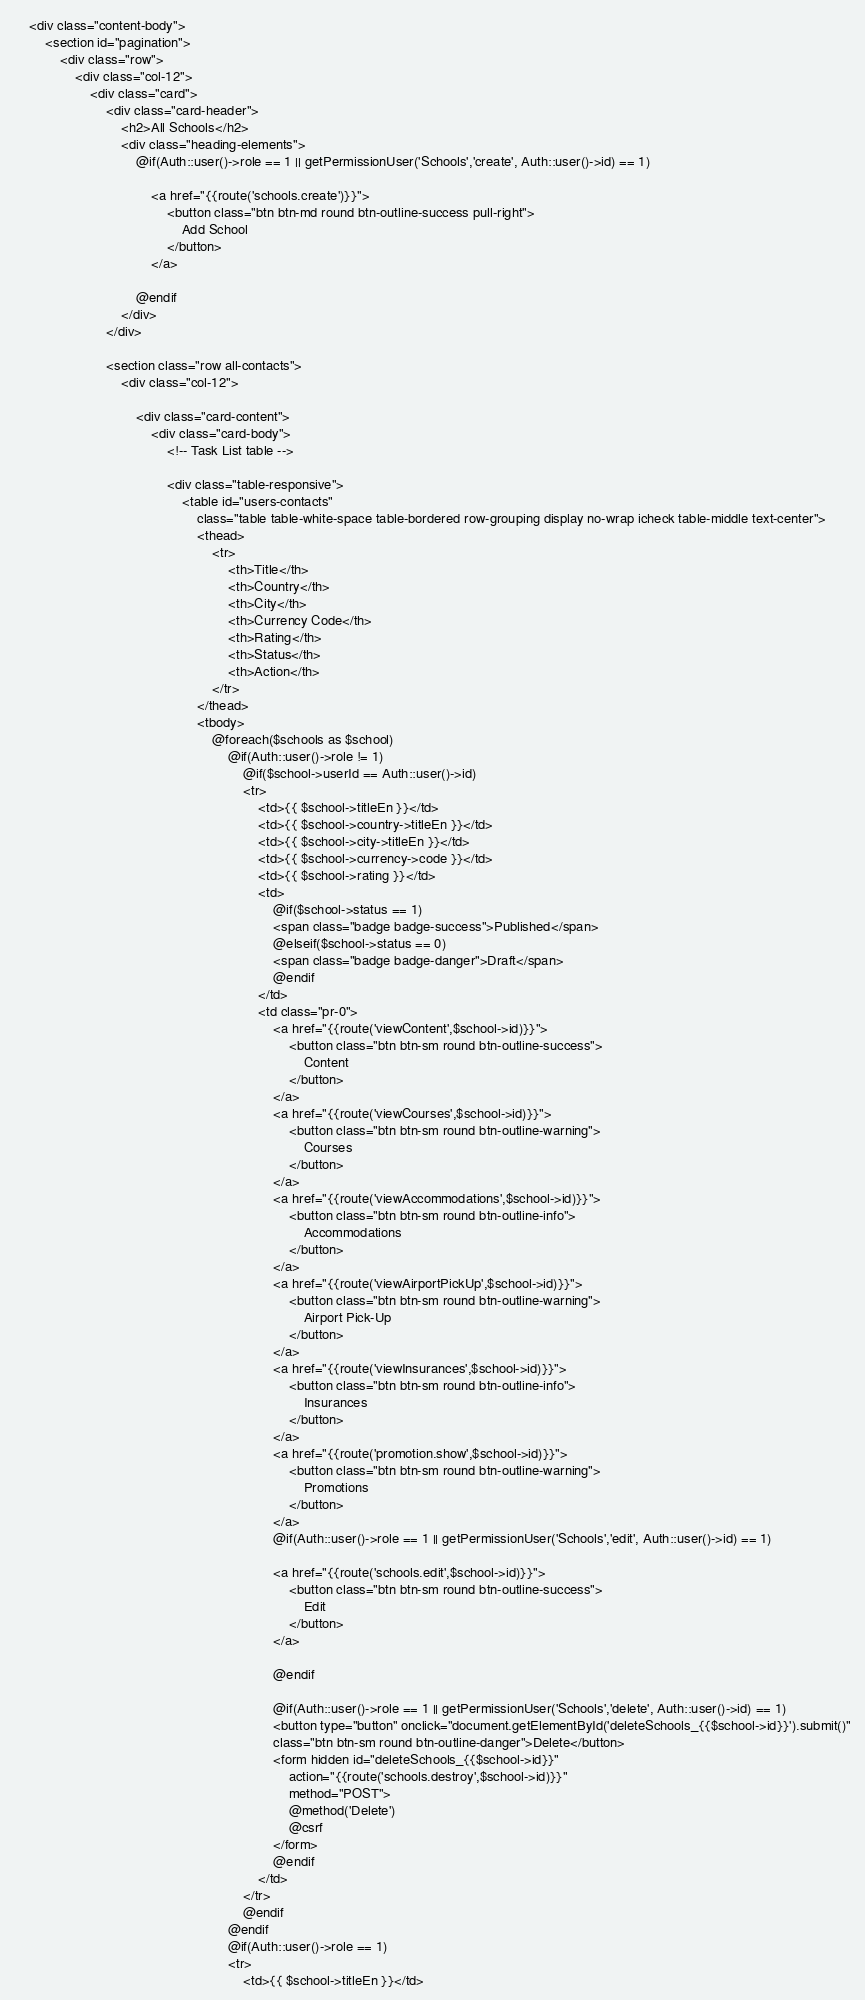<code> <loc_0><loc_0><loc_500><loc_500><_PHP_>    <div class="content-body">
        <section id="pagination">
            <div class="row">
                <div class="col-12">
                    <div class="card">
                        <div class="card-header">
                            <h2>All Schools</h2>
                            <div class="heading-elements">
                                @if(Auth::user()->role == 1 || getPermissionUser('Schools','create', Auth::user()->id) == 1)

                                    <a href="{{route('schools.create')}}">
                                        <button class="btn btn-md round btn-outline-success pull-right">
                                            Add School
                                        </button>
                                    </a>

                                @endif
                            </div>
                        </div>

                        <section class="row all-contacts">
                            <div class="col-12">

                                <div class="card-content">
                                    <div class="card-body">
                                        <!-- Task List table -->

                                        <div class="table-responsive">
                                            <table id="users-contacts"
                                                class="table table-white-space table-bordered row-grouping display no-wrap icheck table-middle text-center">
                                                <thead>
                                                    <tr>
                                                        <th>Title</th>
                                                        <th>Country</th>
                                                        <th>City</th>
                                                        <th>Currency Code</th>
                                                        <th>Rating</th>
                                                        <th>Status</th>
                                                        <th>Action</th>
                                                    </tr>
                                                </thead>
                                                <tbody>
                                                    @foreach($schools as $school)
                                                        @if(Auth::user()->role != 1)
                                                            @if($school->userId == Auth::user()->id)
                                                            <tr>
                                                                <td>{{ $school->titleEn }}</td>
                                                                <td>{{ $school->country->titleEn }}</td>
                                                                <td>{{ $school->city->titleEn }}</td>
                                                                <td>{{ $school->currency->code }}</td>
                                                                <td>{{ $school->rating }}</td>
                                                                <td>
                                                                    @if($school->status == 1)
                                                                    <span class="badge badge-success">Published</span>
                                                                    @elseif($school->status == 0)
                                                                    <span class="badge badge-danger">Draft</span>
                                                                    @endif
                                                                </td>
                                                                <td class="pr-0">
                                                                    <a href="{{route('viewContent',$school->id)}}">
                                                                        <button class="btn btn-sm round btn-outline-success">
                                                                            Content
                                                                        </button>
                                                                    </a>
                                                                    <a href="{{route('viewCourses',$school->id)}}">
                                                                        <button class="btn btn-sm round btn-outline-warning">
                                                                            Courses
                                                                        </button>
                                                                    </a>
                                                                    <a href="{{route('viewAccommodations',$school->id)}}">
                                                                        <button class="btn btn-sm round btn-outline-info">
                                                                            Accommodations
                                                                        </button>
                                                                    </a>
                                                                    <a href="{{route('viewAirportPickUp',$school->id)}}">
                                                                        <button class="btn btn-sm round btn-outline-warning">
                                                                            Airport Pick-Up
                                                                        </button>
                                                                    </a>
                                                                    <a href="{{route('viewInsurances',$school->id)}}">
                                                                        <button class="btn btn-sm round btn-outline-info">
                                                                            Insurances
                                                                        </button>
                                                                    </a>
                                                                    <a href="{{route('promotion.show',$school->id)}}">
                                                                        <button class="btn btn-sm round btn-outline-warning">
                                                                            Promotions
                                                                        </button>
                                                                    </a>
                                                                    @if(Auth::user()->role == 1 || getPermissionUser('Schools','edit', Auth::user()->id) == 1)

                                                                    <a href="{{route('schools.edit',$school->id)}}">
                                                                        <button class="btn btn-sm round btn-outline-success">
                                                                            Edit
                                                                        </button>
                                                                    </a>
                                                                    
                                                                    @endif

                                                                    @if(Auth::user()->role == 1 || getPermissionUser('Schools','delete', Auth::user()->id) == 1)
                                                                    <button type="button" onclick="document.getElementById('deleteSchools_{{$school->id}}').submit()"
                                                                    class="btn btn-sm round btn-outline-danger">Delete</button>
                                                                    <form hidden id="deleteSchools_{{$school->id}}"
                                                                        action="{{route('schools.destroy',$school->id)}}"
                                                                        method="POST">
                                                                        @method('Delete')
                                                                        @csrf
                                                                    </form>
                                                                    @endif
                                                                </td>
                                                            </tr>
                                                            @endif
                                                        @endif
                                                        @if(Auth::user()->role == 1)
                                                        <tr>
                                                            <td>{{ $school->titleEn }}</td></code> 